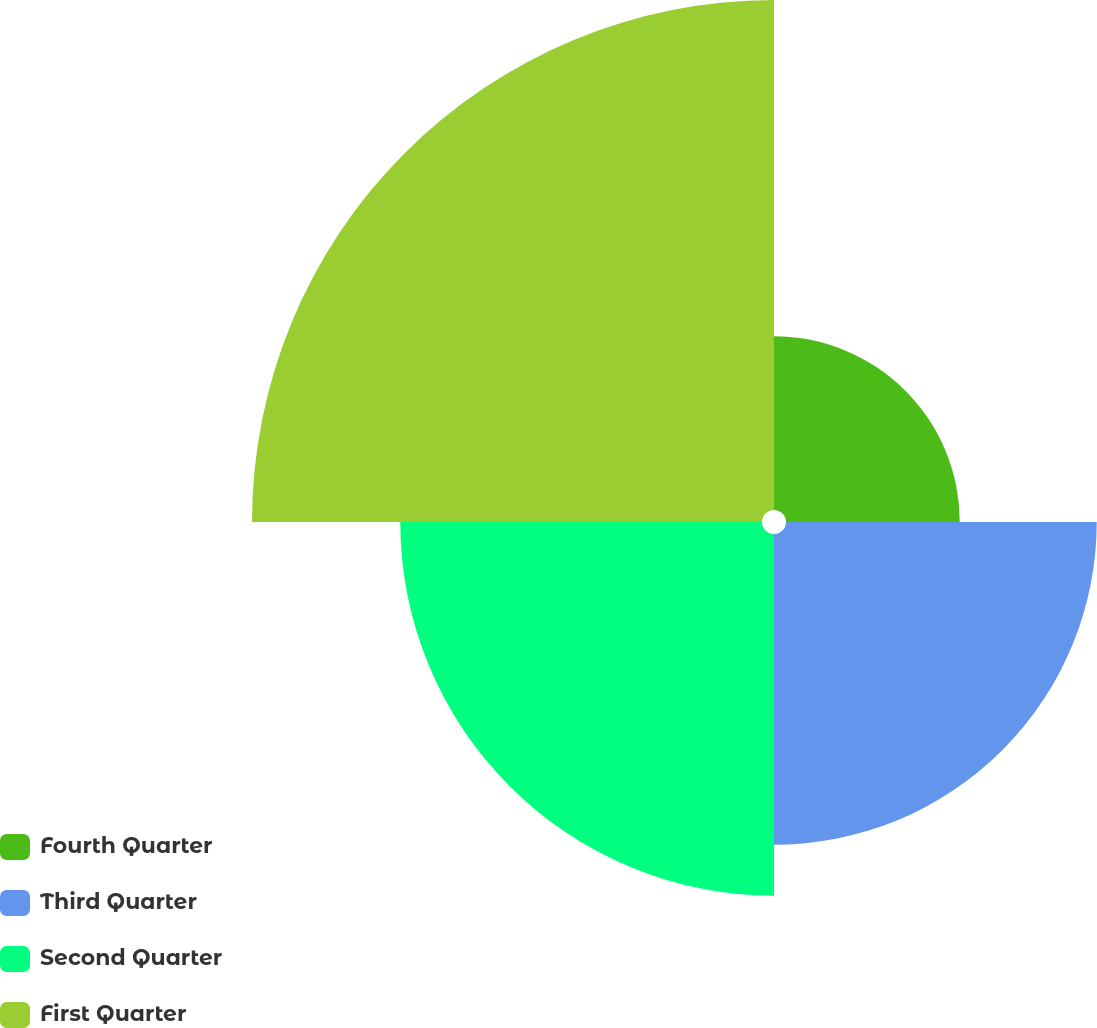Convert chart to OTSL. <chart><loc_0><loc_0><loc_500><loc_500><pie_chart><fcel>Fourth Quarter<fcel>Third Quarter<fcel>Second Quarter<fcel>First Quarter<nl><fcel>12.81%<fcel>22.91%<fcel>26.67%<fcel>37.6%<nl></chart> 